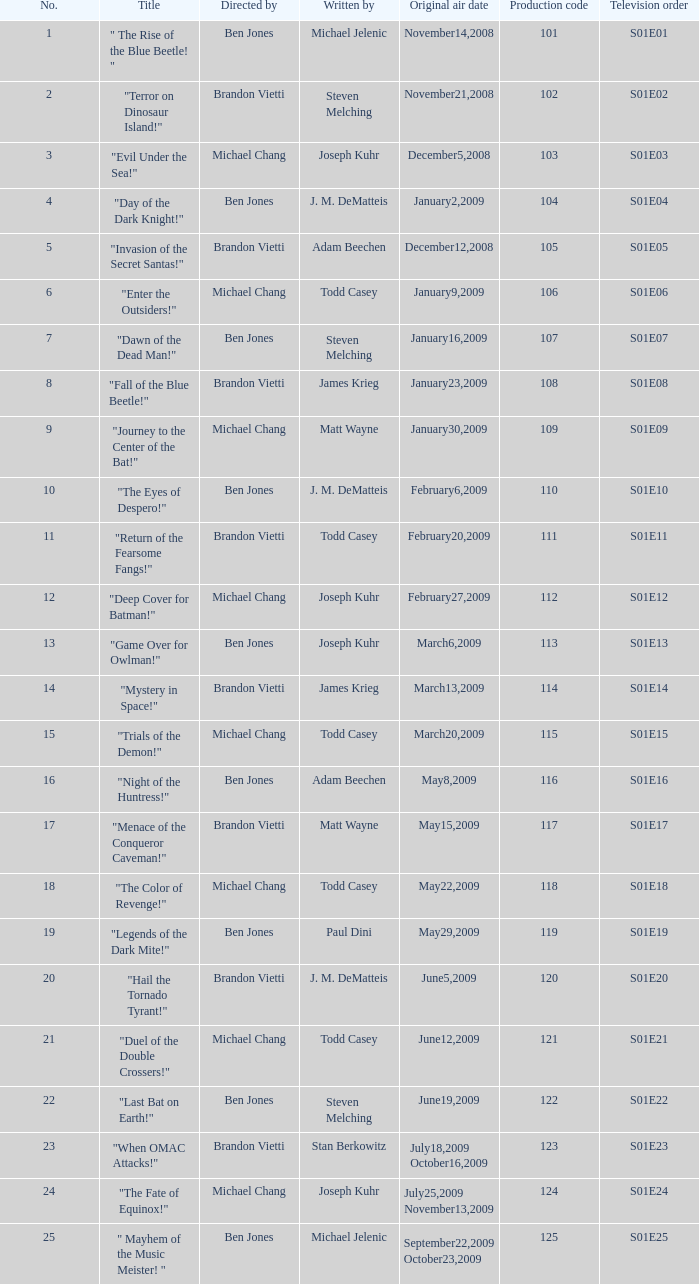What is the the television order of "deep cover for batman!" S01E12. 